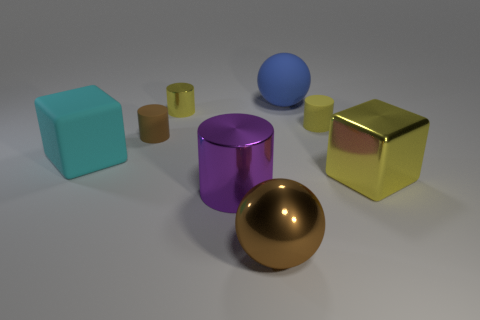Add 1 purple objects. How many objects exist? 9 Subtract all spheres. How many objects are left? 6 Add 3 gray things. How many gray things exist? 3 Subtract 0 brown cubes. How many objects are left? 8 Subtract all tiny gray rubber spheres. Subtract all tiny matte things. How many objects are left? 6 Add 8 yellow metallic cylinders. How many yellow metallic cylinders are left? 9 